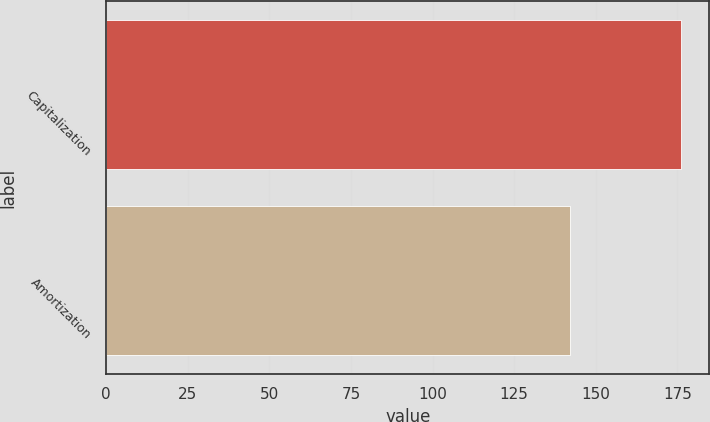Convert chart to OTSL. <chart><loc_0><loc_0><loc_500><loc_500><bar_chart><fcel>Capitalization<fcel>Amortization<nl><fcel>176<fcel>142<nl></chart> 